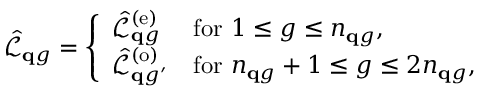Convert formula to latex. <formula><loc_0><loc_0><loc_500><loc_500>\hat { \mathcal { L } } _ { \mathbf q g } = \left \{ \begin{array} { l l } { \hat { \mathcal { L } } _ { \mathbf q g } ^ { ( e ) } } & { f o r { 1 \leq { g } \leq n _ { q g } } , } \\ { \hat { \mathcal { L } } _ { { \mathbf q g ^ { \prime } } } ^ { ( o ) } } & { f o r { n _ { q g } + 1 \leq { g } \leq { 2 n _ { q g } } } , } \end{array}</formula> 